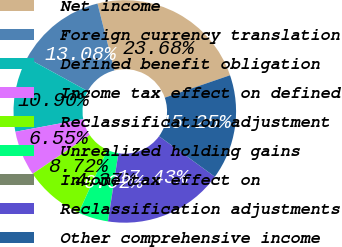<chart> <loc_0><loc_0><loc_500><loc_500><pie_chart><fcel>Net income<fcel>Foreign currency translation<fcel>Defined benefit obligation<fcel>Income tax effect on defined<fcel>Reclassification adjustment<fcel>Unrealized holding gains<fcel>Income tax effect on<fcel>Reclassification adjustments<fcel>Other comprehensive income<nl><fcel>23.68%<fcel>13.08%<fcel>10.9%<fcel>6.55%<fcel>8.72%<fcel>4.37%<fcel>0.02%<fcel>17.43%<fcel>15.25%<nl></chart> 